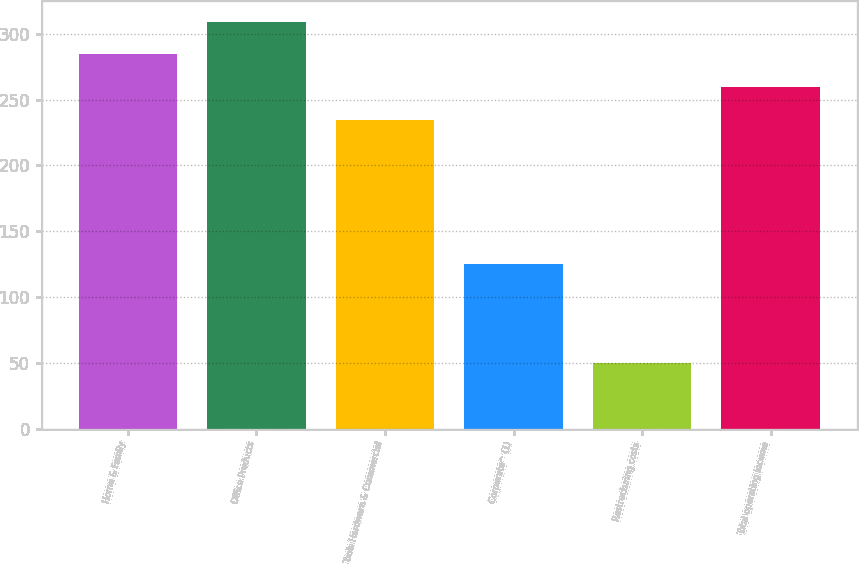Convert chart. <chart><loc_0><loc_0><loc_500><loc_500><bar_chart><fcel>Home & Family<fcel>Office Products<fcel>Tools Hardware & Commercial<fcel>Corporate^ (1)<fcel>Restructuring costs<fcel>Total operating income<nl><fcel>284.32<fcel>309.33<fcel>234.3<fcel>125.1<fcel>50.1<fcel>259.31<nl></chart> 